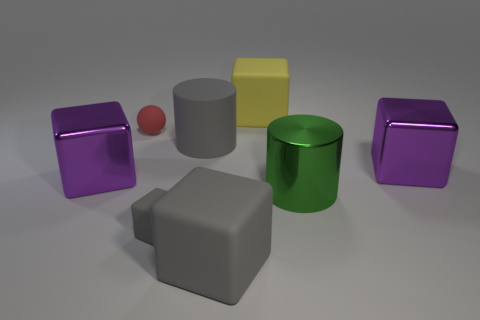Subtract all yellow blocks. How many blocks are left? 4 Subtract all tiny gray matte blocks. How many blocks are left? 4 Subtract all red cubes. Subtract all cyan spheres. How many cubes are left? 5 Add 1 tiny green cylinders. How many objects exist? 9 Subtract all spheres. How many objects are left? 7 Add 4 large gray cylinders. How many large gray cylinders are left? 5 Add 5 matte cylinders. How many matte cylinders exist? 6 Subtract 0 brown cubes. How many objects are left? 8 Subtract all large gray spheres. Subtract all gray things. How many objects are left? 5 